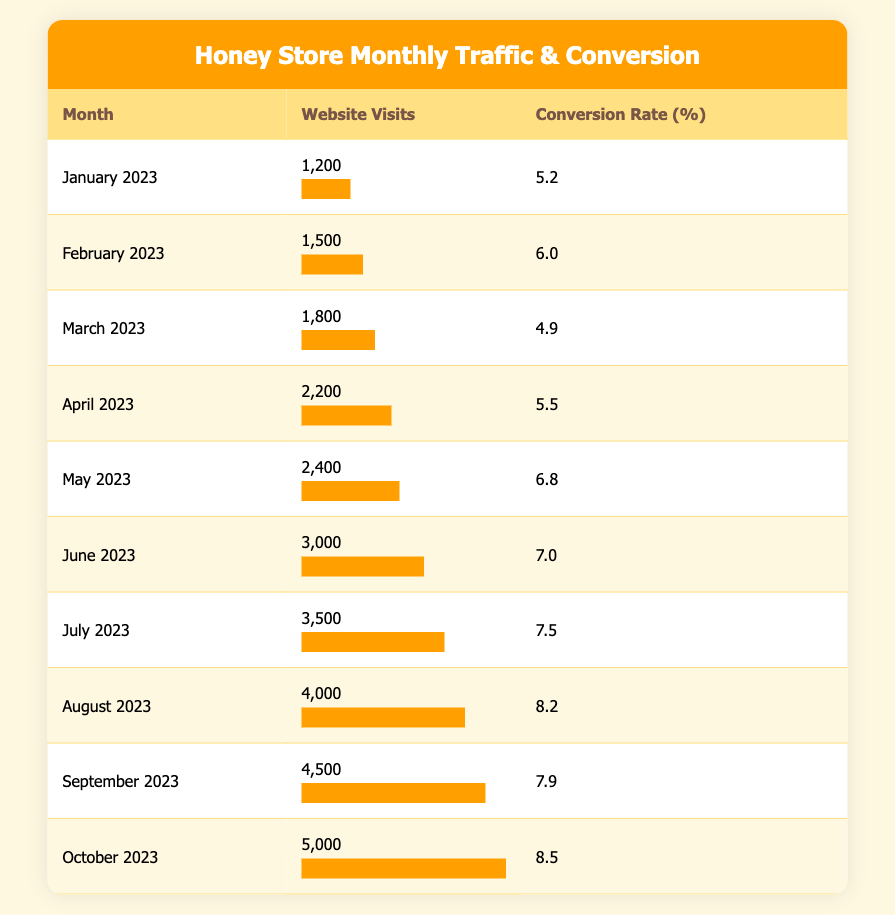What's the conversion rate in May 2023? By looking at the table, we can find that May 2023 has a conversion rate of 6.8%.
Answer: 6.8 Which month had the highest website visits? According to the data, October 2023 shows the highest number of website visits at 5000.
Answer: October 2023 What is the average conversion rate from January to October 2023? To find the average conversion rate, we sum all conversion rates: (5.2 + 6.0 + 4.9 + 5.5 + 6.8 + 7.0 + 7.5 + 8.2 + 7.9 + 8.5) = 58.5. Then, we divide by the number of months (10): 58.5 / 10 = 5.85.
Answer: 5.85 Did the conversion rate increase from June to July 2023? Looking at the data, the conversion rate in June 2023 was 7.0%, and in July 2023, it was 7.5%. Since 7.5 is greater than 7.0, the conversion rate did increase.
Answer: Yes What is the total number of website visits from January to April 2023? We can sum the website visits from January through April: 1200 + 1500 + 1800 + 2200 = 6700. Thus, the total website visits are 6700.
Answer: 6700 In which month was the conversion rate lowest, and what was it? By comparing all the conversion rates in the table, March 2023 has the lowest conversion rate of 4.9%.
Answer: March 2023, 4.9 How much did website visits increase from June to October 2023? In June 2023, the website visits were 3000, and in October 2023, they were 5000. The increase is 5000 - 3000 = 2000.
Answer: 2000 Was there a month where the conversion rate was higher than 8%? Checking the conversion rates, both August 2023 (8.2) and October 2023 (8.5) had conversion rates higher than 8%. Therefore, the answer is yes.
Answer: Yes 